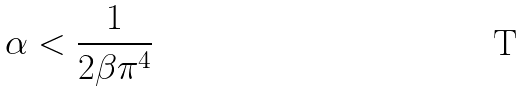Convert formula to latex. <formula><loc_0><loc_0><loc_500><loc_500>\alpha < \frac { 1 } { 2 \beta \pi ^ { 4 } }</formula> 